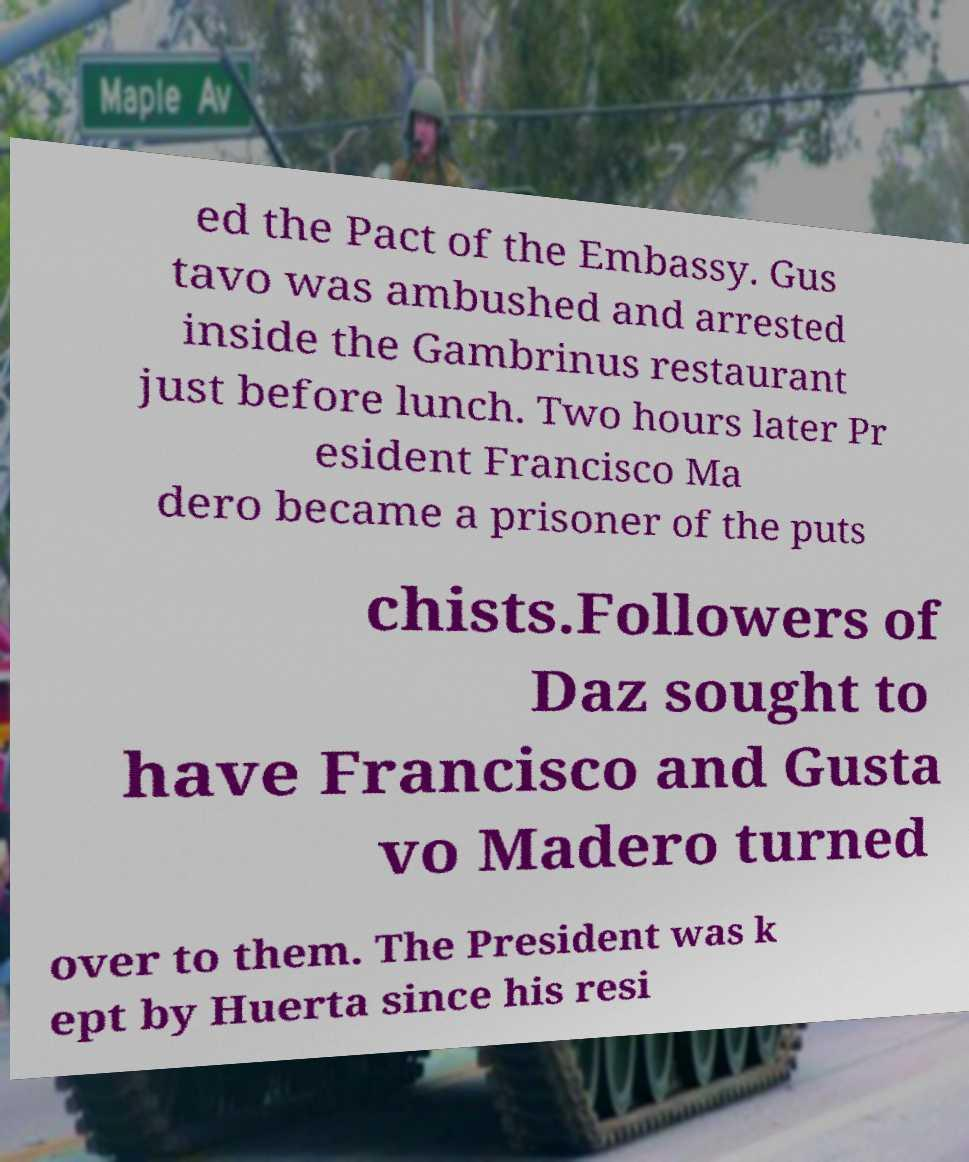Please read and relay the text visible in this image. What does it say? ed the Pact of the Embassy. Gus tavo was ambushed and arrested inside the Gambrinus restaurant just before lunch. Two hours later Pr esident Francisco Ma dero became a prisoner of the puts chists.Followers of Daz sought to have Francisco and Gusta vo Madero turned over to them. The President was k ept by Huerta since his resi 